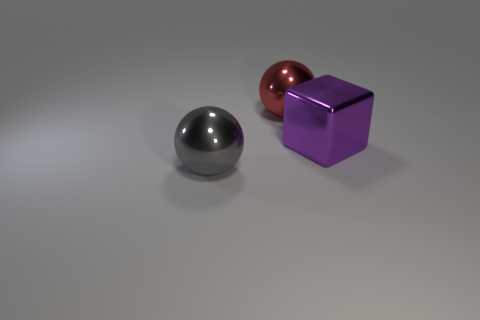Add 2 big purple metallic objects. How many objects exist? 5 Subtract 1 blocks. How many blocks are left? 0 Add 2 large cyan shiny spheres. How many large cyan shiny spheres exist? 2 Subtract all red balls. How many balls are left? 1 Subtract 0 purple spheres. How many objects are left? 3 Subtract all balls. How many objects are left? 1 Subtract all purple balls. Subtract all yellow cylinders. How many balls are left? 2 Subtract all green blocks. How many gray spheres are left? 1 Subtract all red metallic spheres. Subtract all shiny spheres. How many objects are left? 0 Add 2 large gray metallic things. How many large gray metallic things are left? 3 